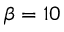Convert formula to latex. <formula><loc_0><loc_0><loc_500><loc_500>\beta = 1 0</formula> 